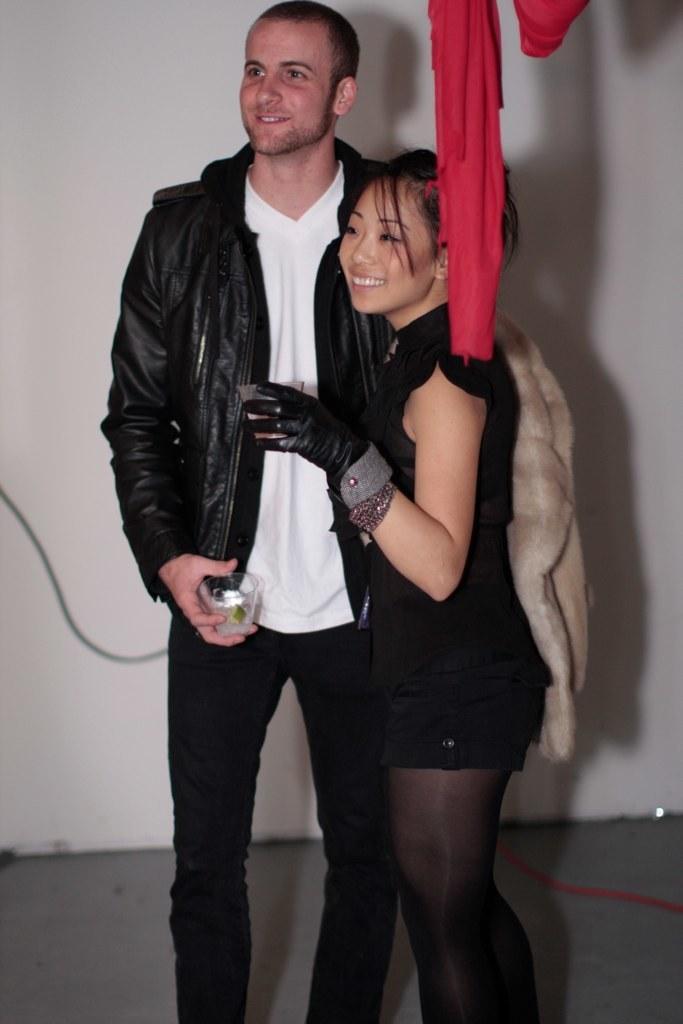How would you summarize this image in a sentence or two? In this image, I can see two persons standing and smiling. These two persons are holding the glasses. At the top of the image, I can see a red cloth. In the background, there is a wall. 